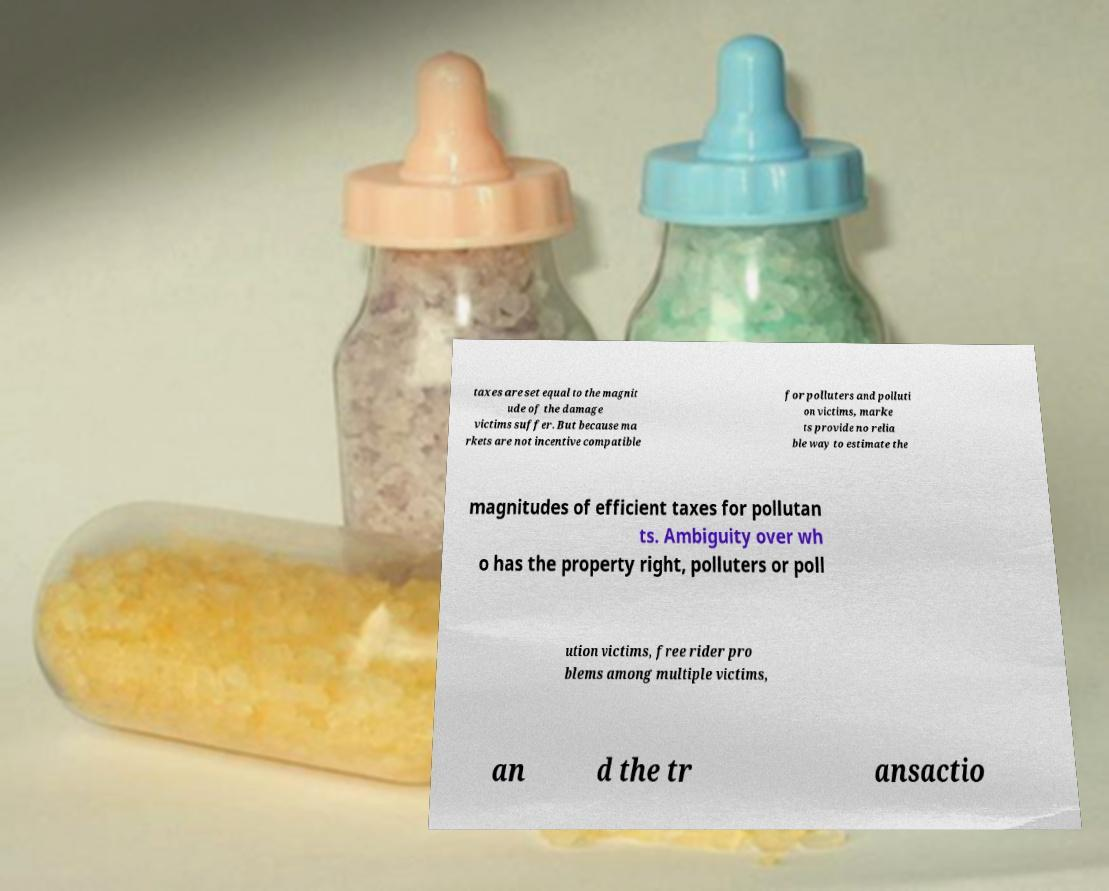Please read and relay the text visible in this image. What does it say? taxes are set equal to the magnit ude of the damage victims suffer. But because ma rkets are not incentive compatible for polluters and polluti on victims, marke ts provide no relia ble way to estimate the magnitudes of efficient taxes for pollutan ts. Ambiguity over wh o has the property right, polluters or poll ution victims, free rider pro blems among multiple victims, an d the tr ansactio 